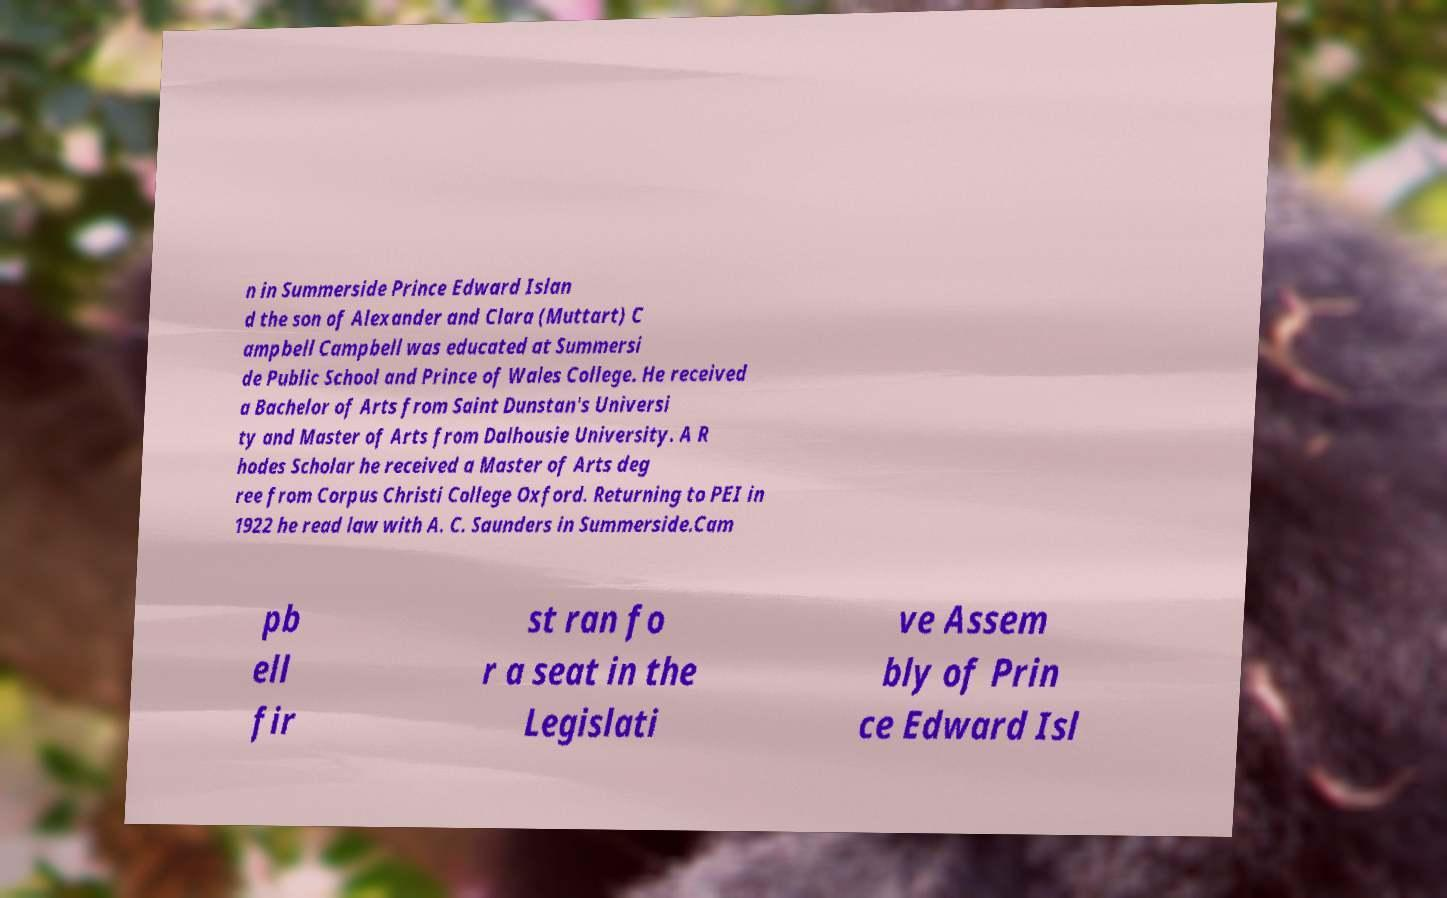Please read and relay the text visible in this image. What does it say? n in Summerside Prince Edward Islan d the son of Alexander and Clara (Muttart) C ampbell Campbell was educated at Summersi de Public School and Prince of Wales College. He received a Bachelor of Arts from Saint Dunstan's Universi ty and Master of Arts from Dalhousie University. A R hodes Scholar he received a Master of Arts deg ree from Corpus Christi College Oxford. Returning to PEI in 1922 he read law with A. C. Saunders in Summerside.Cam pb ell fir st ran fo r a seat in the Legislati ve Assem bly of Prin ce Edward Isl 